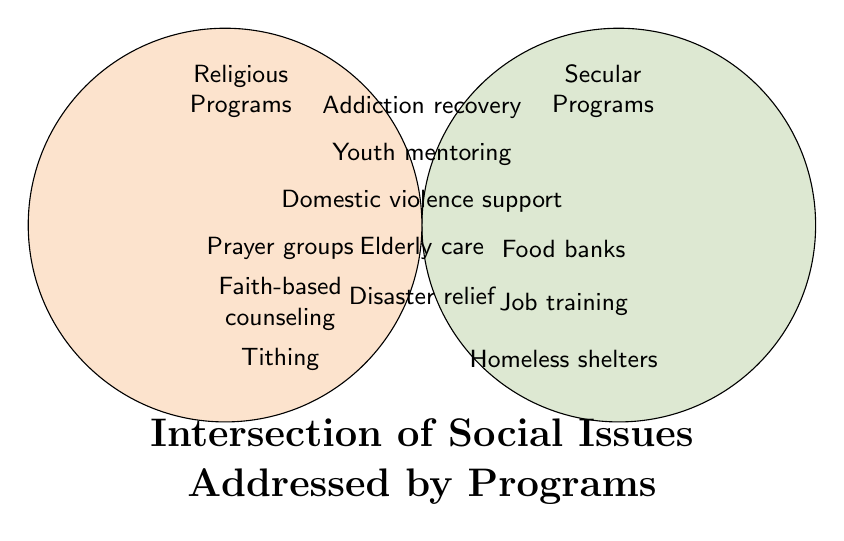What are the categories mentioned in the Venn Diagram? The Venn Diagram showcases three categories: Secular Programs, Religious Programs, and programs addressed by Both. These categories are visually represented by two overlapping circles, with the intersection representing programs addressed by both types.
Answer: Secular, Religious, Both Which programs fall under both categories? The programs listed within the intersection of the Venn Diagram are those tackled by both secular and religious programs. These are displayed in the overlapping area of the two circles. The listed programs include addiction recovery programs, youth mentoring, domestic violence support, elderly care services, and disaster relief efforts.
Answer: Addiction recovery programs, Youth mentoring, Domestic violence support, Elderly care services, Disaster relief efforts What are three programs that are only addressed by religious programs? The programs exclusive to the religious category are listed solely within the circle labeled for Religious Programs, which does not overlap with the Secular Programs circle. These programs include prayer groups, faith-based counseling, and tithing.
Answer: Prayer groups, Faith-based counseling, Tithing Which type of program appears to be more comprehensive, addressing more social issues? This question requires counting the programs in both categories. Secular Programs address three social issues: food banks, job training, and homeless shelters. Religious Programs also address three: prayer groups, faith-based counseling, and tithing. Both address five issues: addiction recovery, youth mentoring, domestic violence support, elderly care, and disaster relief. Therefore, "Both" category is the most comprehensive, addressing five issues.
Answer: Both category Compare the focus areas of secular programs versus religious programs. Which addresses more distinct areas? Secular programs focus areas include food banks, job training, and homeless shelters, adding up to three distinct areas. Religious programs focus on prayer groups, faith-based counseling, and tithing, also adding up to three distinct areas. Both address an intersection of five focus areas. Hence, secular and religious programs each address three distinct areas, equally.
Answer: They address the same number of distinct areas Which programs are specifically offered by secular but not by religious programs? By inspecting the circle labeled "Secular Programs" and checking for non-overlapping items, the programs offered specifically by secular programs are food banks, job training, and homeless shelters. These are not part of the intersection with religious programs.
Answer: Food banks, Job training, Homeless shelters How many total distinct types of programs are presented in the Venn Diagram? Adding all unique programs from each category, count the programs in Secular (3), Religious (3), and Both (5). The total is 3 (secular) + 3 (religious) + 5 (both), equating to 11 distinct types of programs presented.
Answer: 11 